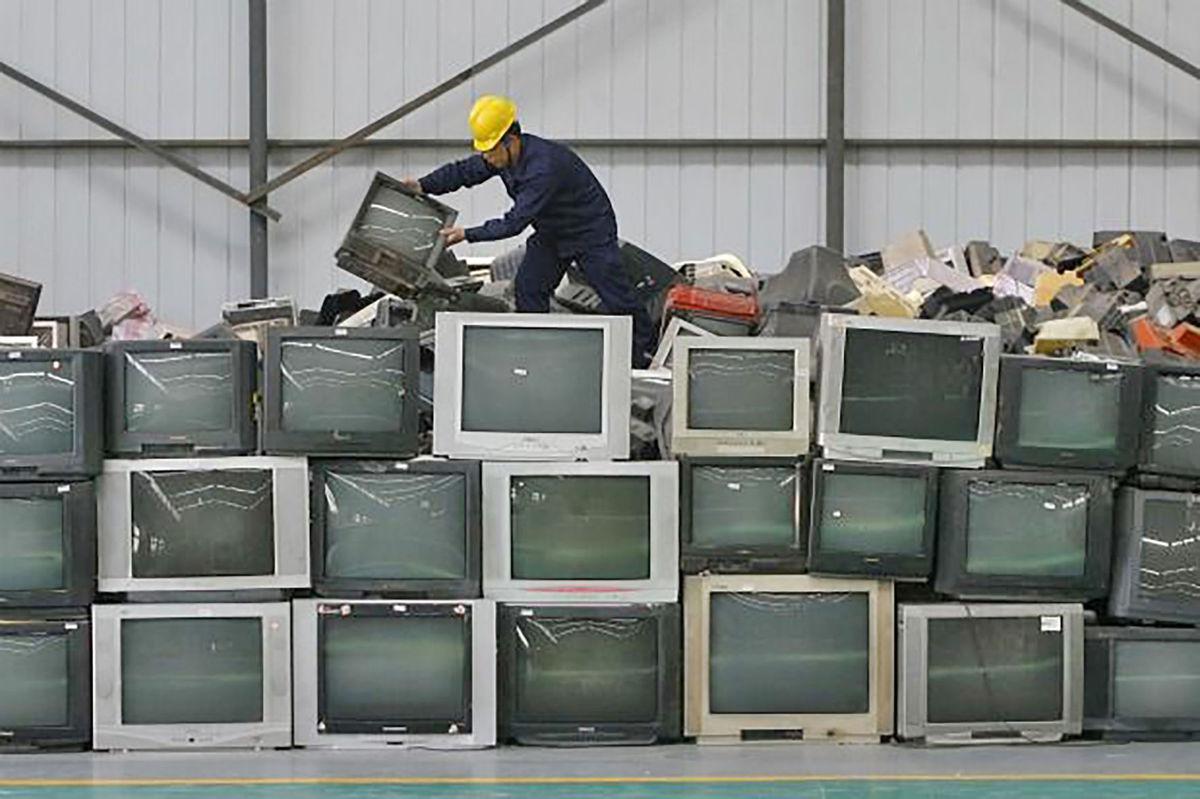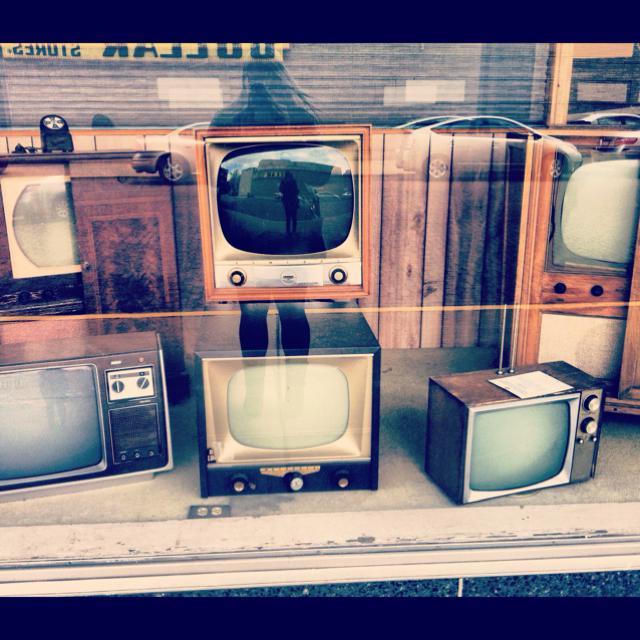The first image is the image on the left, the second image is the image on the right. Analyze the images presented: Is the assertion "At least one television is on." valid? Answer yes or no. No. The first image is the image on the left, the second image is the image on the right. Assess this claim about the two images: "A single console television sits in the image on the right.". Correct or not? Answer yes or no. No. 